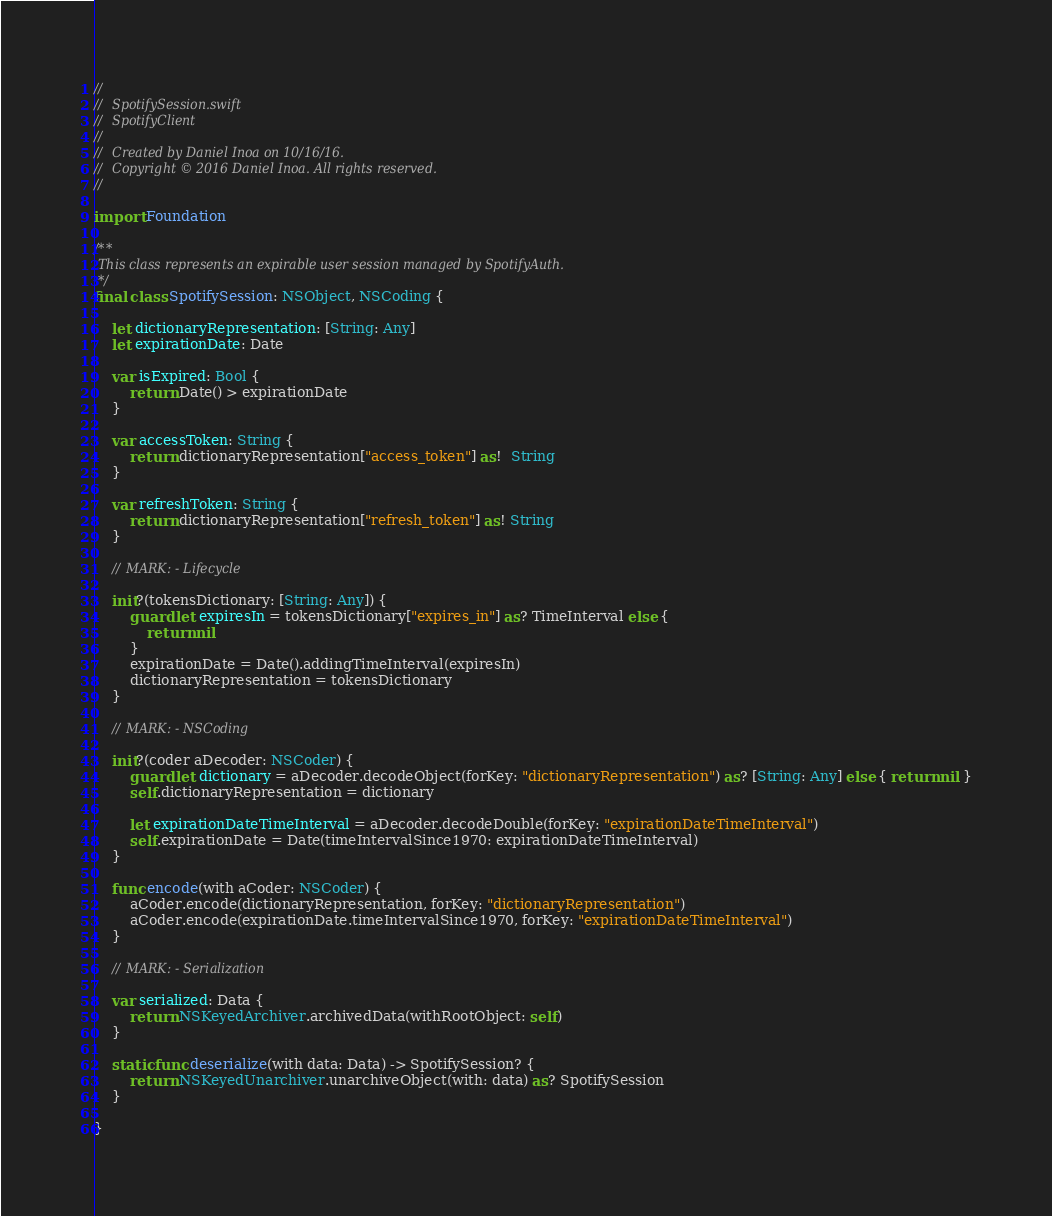<code> <loc_0><loc_0><loc_500><loc_500><_Swift_>//
//  SpotifySession.swift
//  SpotifyClient
//
//  Created by Daniel Inoa on 10/16/16.
//  Copyright © 2016 Daniel Inoa. All rights reserved.
//

import Foundation

/**
 This class represents an expirable user session managed by SpotifyAuth.
 */
final class SpotifySession: NSObject, NSCoding {
    
    let dictionaryRepresentation: [String: Any]
    let expirationDate: Date
    
    var isExpired: Bool {
        return Date() > expirationDate
    }
    
    var accessToken: String {
        return dictionaryRepresentation["access_token"] as!  String
    }
    
    var refreshToken: String {
        return dictionaryRepresentation["refresh_token"] as! String
    }
    
    // MARK: - Lifecycle
    
    init?(tokensDictionary: [String: Any]) {
        guard let expiresIn = tokensDictionary["expires_in"] as? TimeInterval else {
            return nil
        }
        expirationDate = Date().addingTimeInterval(expiresIn)
        dictionaryRepresentation = tokensDictionary
    }
    
    // MARK: - NSCoding
    
    init?(coder aDecoder: NSCoder) {
        guard let dictionary = aDecoder.decodeObject(forKey: "dictionaryRepresentation") as? [String: Any] else { return nil }
        self.dictionaryRepresentation = dictionary
        
        let expirationDateTimeInterval = aDecoder.decodeDouble(forKey: "expirationDateTimeInterval")
        self.expirationDate = Date(timeIntervalSince1970: expirationDateTimeInterval)
    }
    
    func encode(with aCoder: NSCoder) {
        aCoder.encode(dictionaryRepresentation, forKey: "dictionaryRepresentation")
        aCoder.encode(expirationDate.timeIntervalSince1970, forKey: "expirationDateTimeInterval")
    }
    
    // MARK: - Serialization
    
    var serialized: Data {
        return NSKeyedArchiver.archivedData(withRootObject: self)
    }
    
    static func deserialize(with data: Data) -> SpotifySession? {
        return NSKeyedUnarchiver.unarchiveObject(with: data) as? SpotifySession
    }
    
}
</code> 